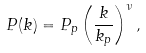<formula> <loc_0><loc_0><loc_500><loc_500>P ( k ) = P _ { p } \left ( \frac { k } { k _ { p } } \right ) ^ { \nu } ,</formula> 